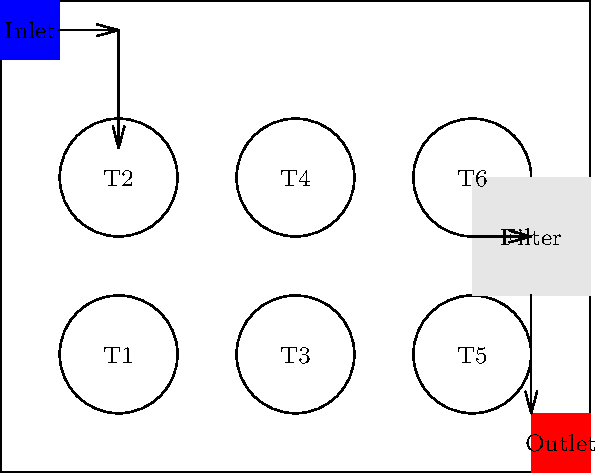Based on the 2D floor plan of an aquaculture facility shown above, which layout modification would most effectively improve water circulation and minimize waste accumulation in the fish tanks? To answer this question, we need to analyze the current layout and identify potential improvements for water circulation and waste management:

1. Current layout analysis:
   - Water enters through the inlet at the top left.
   - Six circular fish tanks are arranged in two rows.
   - A filtration system is located on the right side.
   - Water exits through the outlet at the bottom right.

2. Identifying potential issues:
   - The current layout may lead to uneven water distribution among tanks.
   - Tanks farther from the inlet might receive less fresh water.
   - Waste may accumulate in tanks farther from the filtration system.

3. Considering improvement options:
   a) Rearrange tanks in a circular pattern around the filtration system.
   b) Add a central water distribution channel.
   c) Implement a parallel flow system with individual inlets and outlets for each tank.

4. Evaluating the best solution:
   - Option (c) provides the most efficient water circulation and waste management.
   - Parallel flow ensures equal distribution of fresh water to all tanks.
   - Individual outlets allow for better control of waste removal from each tank.

5. Implementation of the chosen solution:
   - Add individual inlet pipes connecting the main inlet to each tank.
   - Install outlet pipes from each tank leading to the filtration system.
   - Ensure proper sizing of pipes to maintain consistent flow rates.

Therefore, the most effective modification would be to implement a parallel flow system with individual inlets and outlets for each fish tank, improving water circulation and minimizing waste accumulation.
Answer: Implement a parallel flow system with individual inlets and outlets for each tank. 